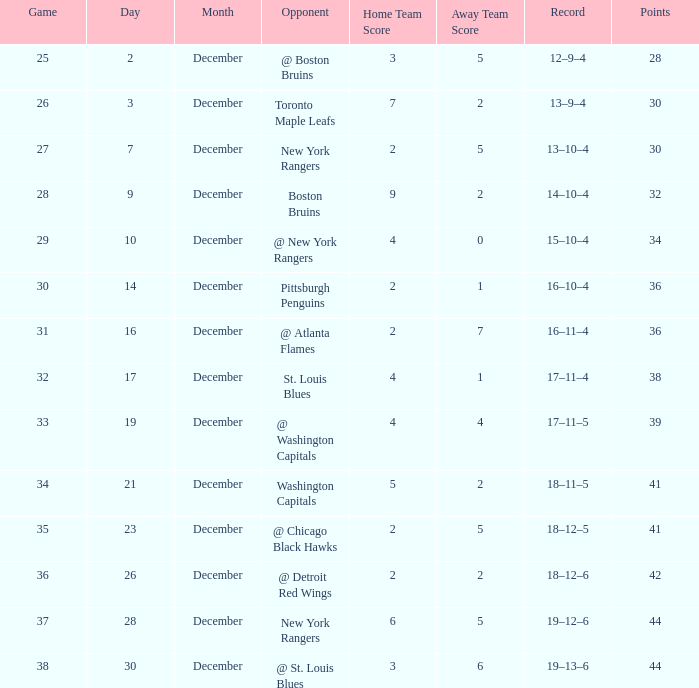What score consists of 36 points and a 30-game? 2–1. Parse the full table. {'header': ['Game', 'Day', 'Month', 'Opponent', 'Home Team Score', 'Away Team Score', 'Record', 'Points'], 'rows': [['25', '2', 'December', '@ Boston Bruins', '3', '5', '12–9–4', '28'], ['26', '3', 'December', 'Toronto Maple Leafs', '7', '2', '13–9–4', '30'], ['27', '7', 'December', 'New York Rangers', '2', '5', '13–10–4', '30'], ['28', '9', 'December', 'Boston Bruins', '9', '2', '14–10–4', '32'], ['29', '10', 'December', '@ New York Rangers', '4', '0', '15–10–4', '34'], ['30', '14', 'December', 'Pittsburgh Penguins', '2', '1', '16–10–4', '36'], ['31', '16', 'December', '@ Atlanta Flames', '2', '7', '16–11–4', '36'], ['32', '17', 'December', 'St. Louis Blues', '4', '1', '17–11–4', '38'], ['33', '19', 'December', '@ Washington Capitals', '4', '4', '17–11–5', '39'], ['34', '21', 'December', 'Washington Capitals', '5', '2', '18–11–5', '41'], ['35', '23', 'December', '@ Chicago Black Hawks', '2', '5', '18–12–5', '41'], ['36', '26', 'December', '@ Detroit Red Wings', '2', '2', '18–12–6', '42'], ['37', '28', 'December', 'New York Rangers', '6', '5', '19–12–6', '44'], ['38', '30', 'December', '@ St. Louis Blues', '3', '6', '19–13–6', '44']]} 